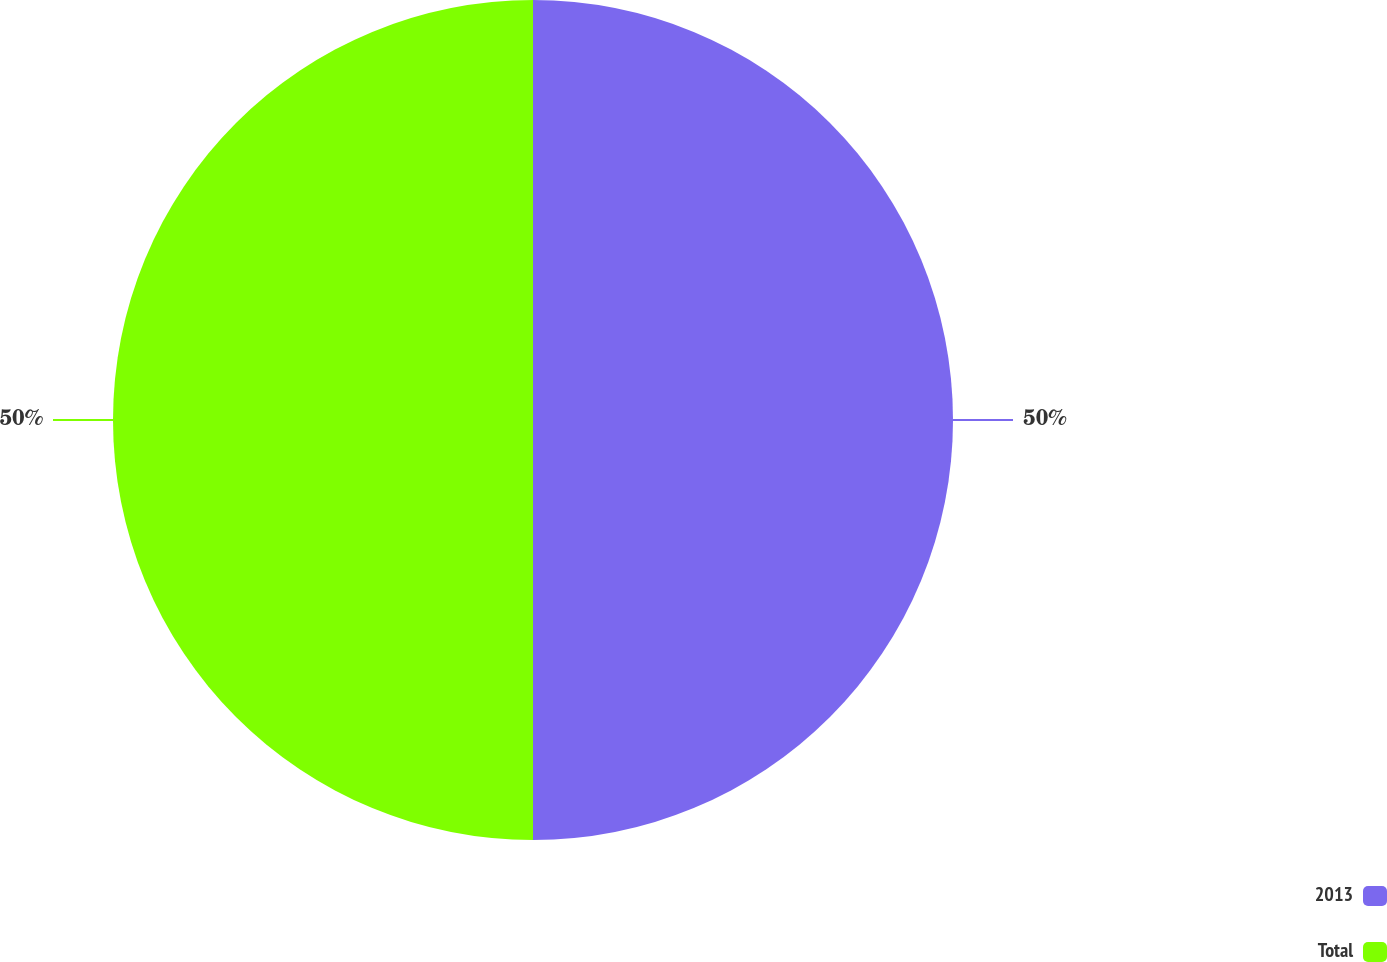Convert chart to OTSL. <chart><loc_0><loc_0><loc_500><loc_500><pie_chart><fcel>2013<fcel>Total<nl><fcel>50.0%<fcel>50.0%<nl></chart> 